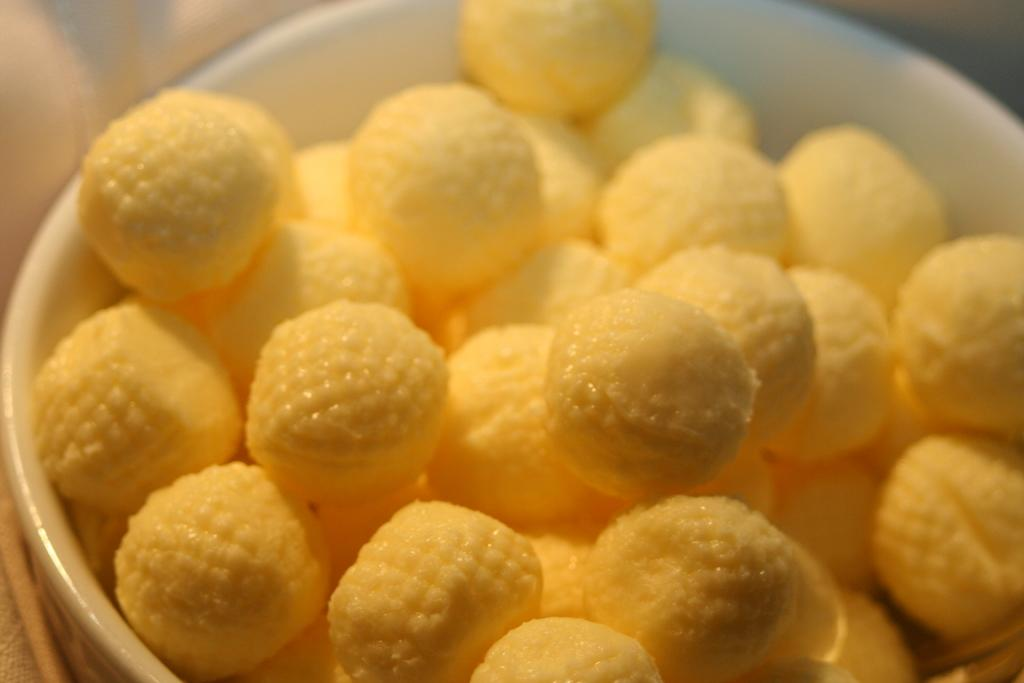What is present in the image? There is a bowl in the image. What color is the bowl? The bowl is white in color. What is inside the bowl? There is food in the bowl. What color is the food? The food is yellow in color. Can you tell me how many grains of rice are in the bowl? There is no indication of the type of food in the bowl, so it is impossible to determine the number of grains of rice. 